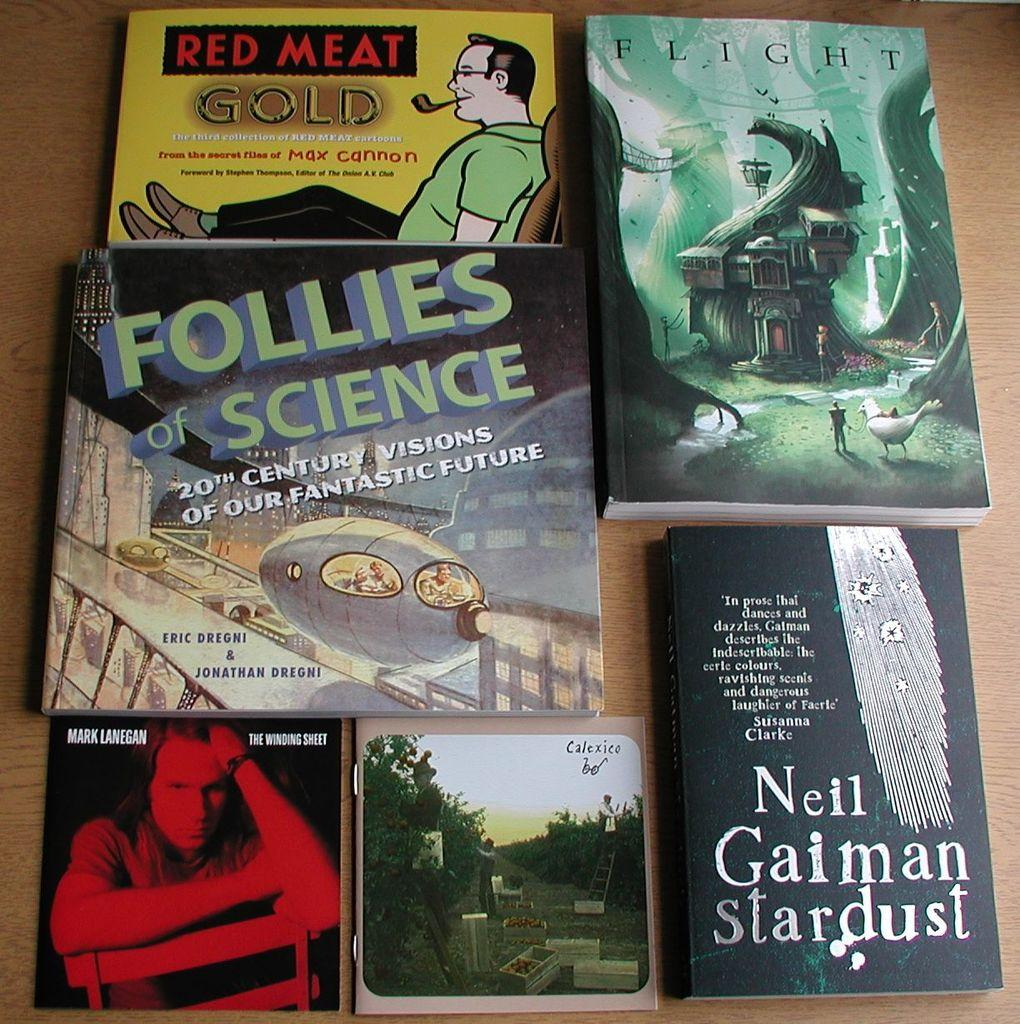<image>
Describe the image concisely. some books and music by Neil Gaiman Stardust and more. 